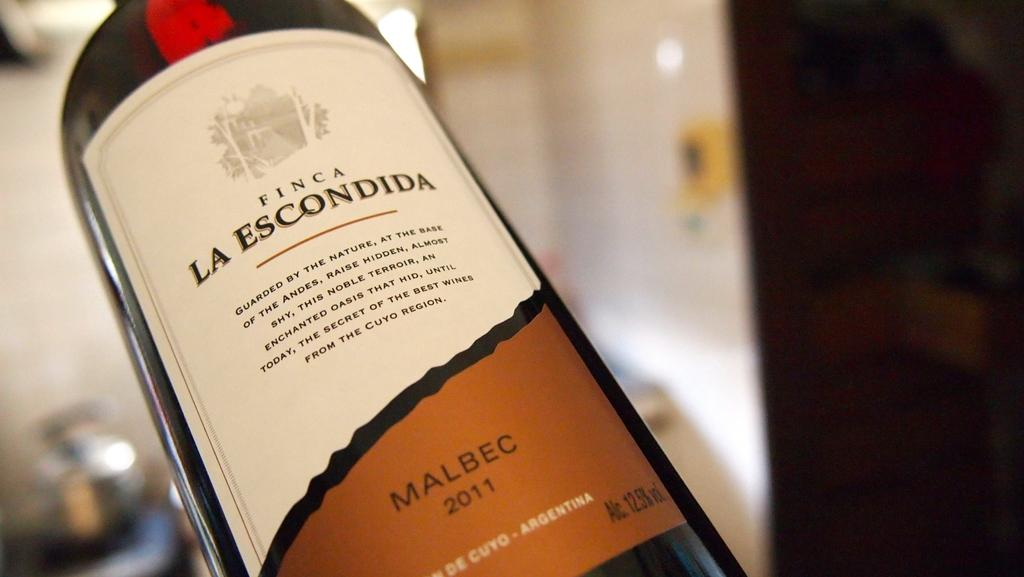<image>
Relay a brief, clear account of the picture shown. Bottle of Finca La escondida wine that is up close in picture 